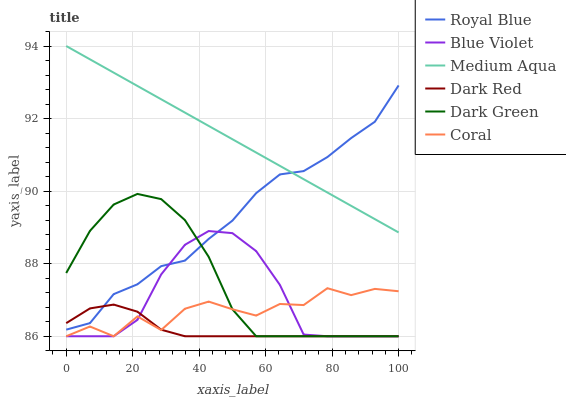Does Dark Red have the minimum area under the curve?
Answer yes or no. Yes. Does Medium Aqua have the maximum area under the curve?
Answer yes or no. Yes. Does Coral have the minimum area under the curve?
Answer yes or no. No. Does Coral have the maximum area under the curve?
Answer yes or no. No. Is Medium Aqua the smoothest?
Answer yes or no. Yes. Is Coral the roughest?
Answer yes or no. Yes. Is Royal Blue the smoothest?
Answer yes or no. No. Is Royal Blue the roughest?
Answer yes or no. No. Does Dark Red have the lowest value?
Answer yes or no. Yes. Does Royal Blue have the lowest value?
Answer yes or no. No. Does Medium Aqua have the highest value?
Answer yes or no. Yes. Does Coral have the highest value?
Answer yes or no. No. Is Dark Red less than Medium Aqua?
Answer yes or no. Yes. Is Medium Aqua greater than Coral?
Answer yes or no. Yes. Does Dark Green intersect Royal Blue?
Answer yes or no. Yes. Is Dark Green less than Royal Blue?
Answer yes or no. No. Is Dark Green greater than Royal Blue?
Answer yes or no. No. Does Dark Red intersect Medium Aqua?
Answer yes or no. No. 